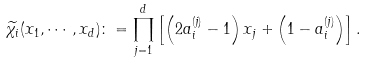<formula> <loc_0><loc_0><loc_500><loc_500>\widetilde { \chi _ { i } } ( x _ { 1 } , \cdots , x _ { d } ) \colon = \prod _ { j = 1 } ^ { d } \left [ \left ( 2 a _ { i } ^ { ( j ) } - 1 \right ) x _ { j } + \left ( 1 - a _ { i } ^ { ( j ) } \right ) \right ] .</formula> 